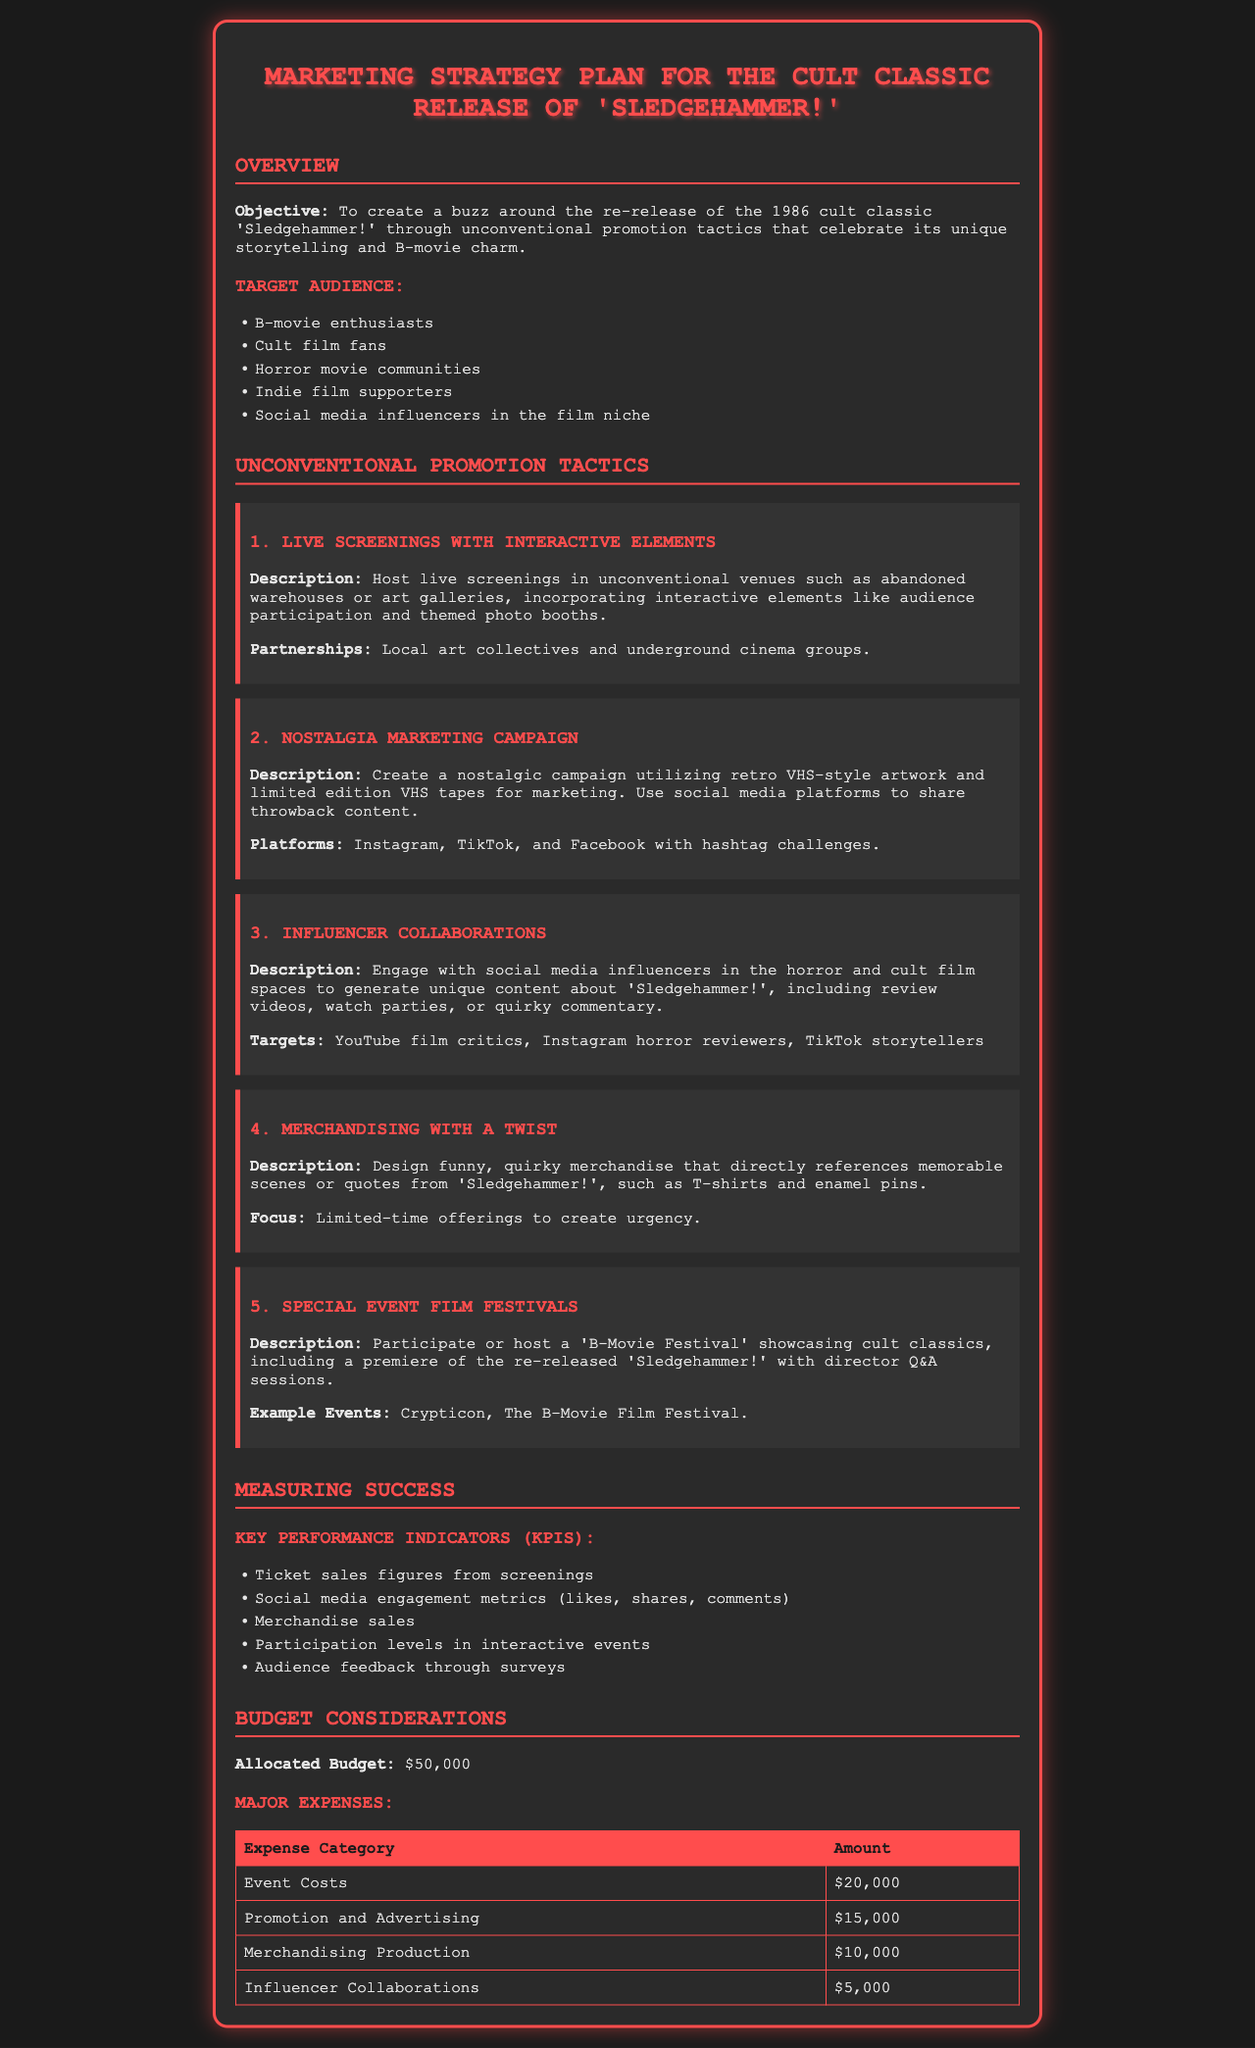What is the objective of the marketing strategy plan? The objective is to create a buzz around the re-release of the 1986 cult classic 'Sledgehammer!' through unconventional promotion tactics that celebrate its unique storytelling and B-movie charm.
Answer: Create a buzz around the re-release Who is one of the target audiences for the campaign? Target audience includes B-movie enthusiasts. This information highlights a specific audience targeted in the marketing strategy.
Answer: B-movie enthusiasts What is the allocated budget for the marketing strategy? The allocated budget is a specific figure mentioned in the document that represents the total financial resources for the plan.
Answer: $50,000 What type of merchandise is mentioned to be offered? Merchandise refers to items specifically created for marketing the film, which includes T-shirts and enamel pins. The answer addresses the kind of products proposed.
Answer: T-shirts and enamel pins How many major expenses categories are outlined in the budget? The number of categories in the budget reflects the structure and breakdown of expenses, which helps understand budget allocation.
Answer: 4 What is one of the KPIs used to measure success? The document lists several performance metrics, making this question focus on one of those indicators for campaign evaluation.
Answer: Ticket sales figures What is the recommended social media platform for nostalgia marketing? The document mentions specific platforms for the campaign, with Instagram being one of them. This focuses on the promotion method suggested.
Answer: Instagram What is one of the events mentioned for the special event film festivals? The document provides examples of events related to the promotion strategy, which indicates a specific event type that will feature 'Sledgehammer!'.
Answer: Crypticon 